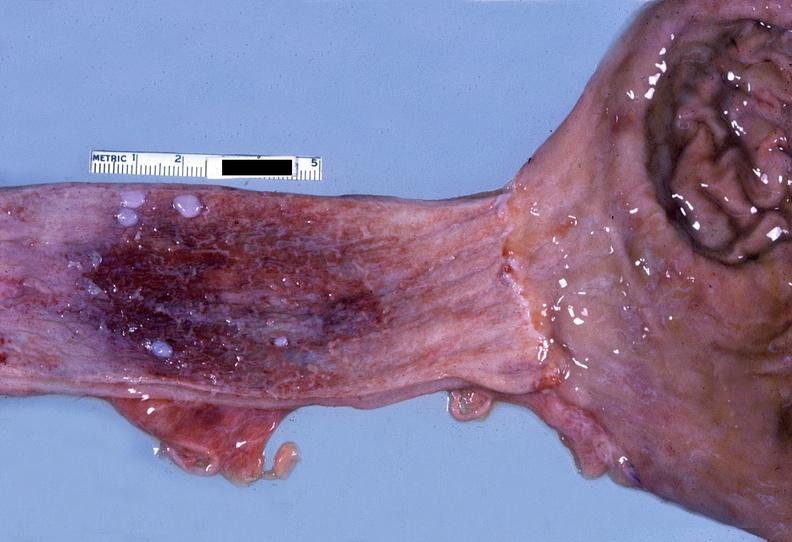what does this image show?
Answer the question using a single word or phrase. Esophagus 